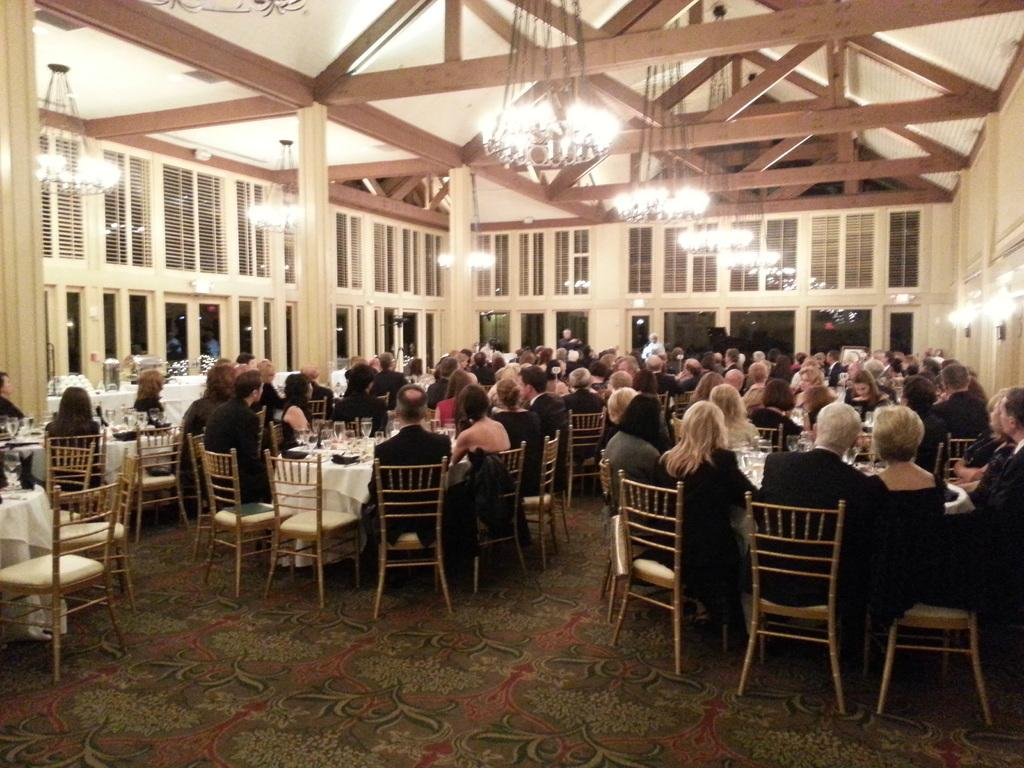How many people are in the image? There is a group of people in the image. What are the people doing in the image? The people are sitting on chairs. What is on the table in the image? There is a glass on the table. What is visible at the top of the image? There are lights visible at the top of the image. What type of trail can be seen in the image? There is no trail present in the image. Can you describe the haircut of the person sitting on the left chair? There is no information about the haircuts of the people in the image. 